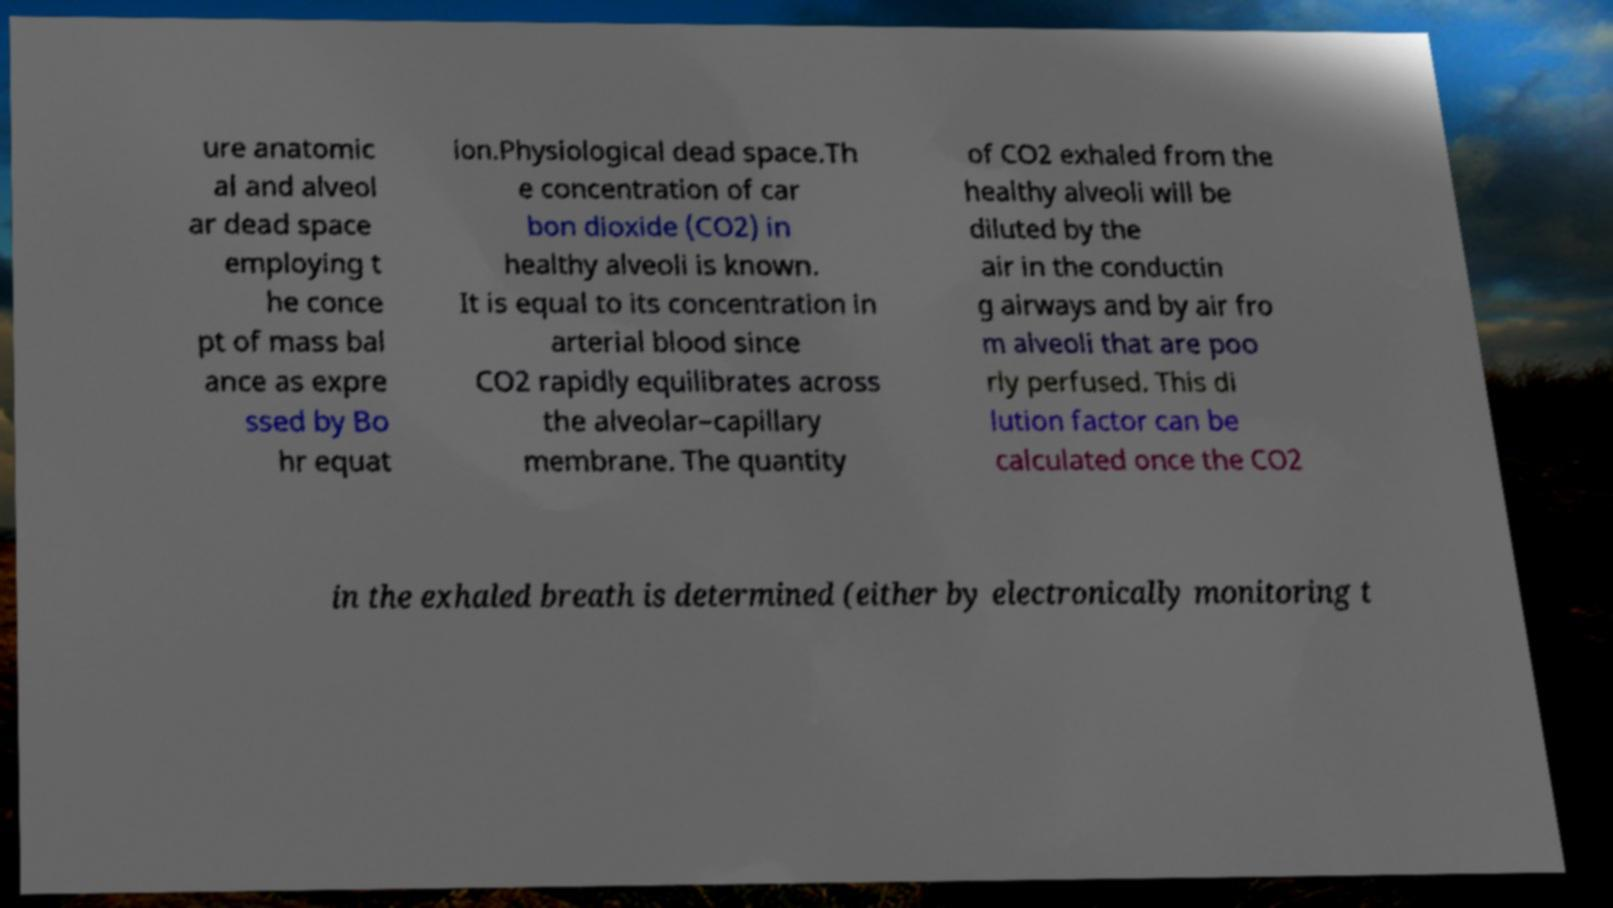Can you accurately transcribe the text from the provided image for me? ure anatomic al and alveol ar dead space employing t he conce pt of mass bal ance as expre ssed by Bo hr equat ion.Physiological dead space.Th e concentration of car bon dioxide (CO2) in healthy alveoli is known. It is equal to its concentration in arterial blood since CO2 rapidly equilibrates across the alveolar–capillary membrane. The quantity of CO2 exhaled from the healthy alveoli will be diluted by the air in the conductin g airways and by air fro m alveoli that are poo rly perfused. This di lution factor can be calculated once the CO2 in the exhaled breath is determined (either by electronically monitoring t 